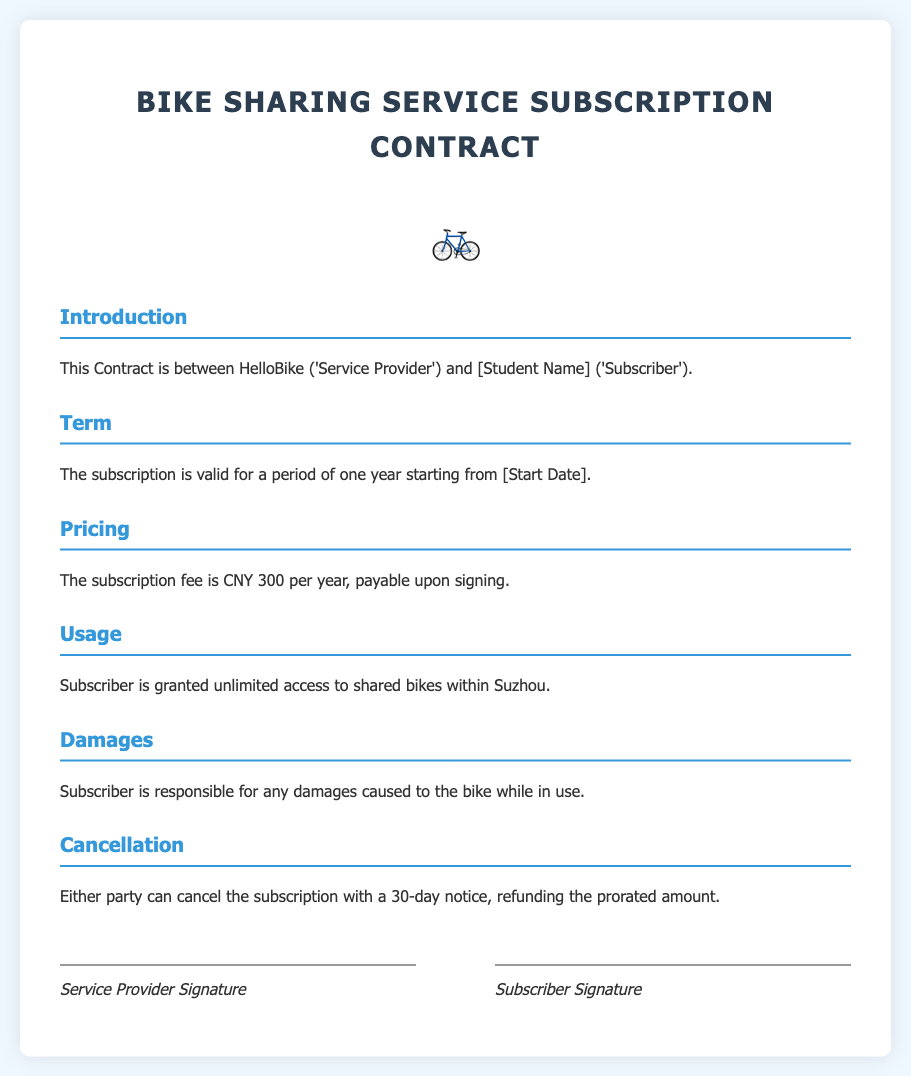What is the name of the Service Provider? The document specifies that the Service Provider is HelloBike.
Answer: HelloBike What is the duration of the subscription? The document states that the subscription is valid for a period of one year.
Answer: One year How much is the annual subscription fee? The subscription fee mentioned in the document is CNY 300 per year.
Answer: CNY 300 What is required for damages to the bike? The document states that the Subscriber is responsible for any damages caused to the bike while in use.
Answer: Responsible How much notice is required for cancellation? The document requires a 30-day notice for cancellation of the subscription.
Answer: 30 days What happens to the subscription fee upon cancellation? The document mentions that the prorated amount is refunded upon cancellation.
Answer: Prorated amount What are Subscribers granted access to? The document mentions that Subscribers are granted unlimited access to shared bikes within Suzhou.
Answer: Unlimited access What is the term start indication in the contract? The document states that the subscription starts from a date indicated as [Start Date].
Answer: [Start Date] 